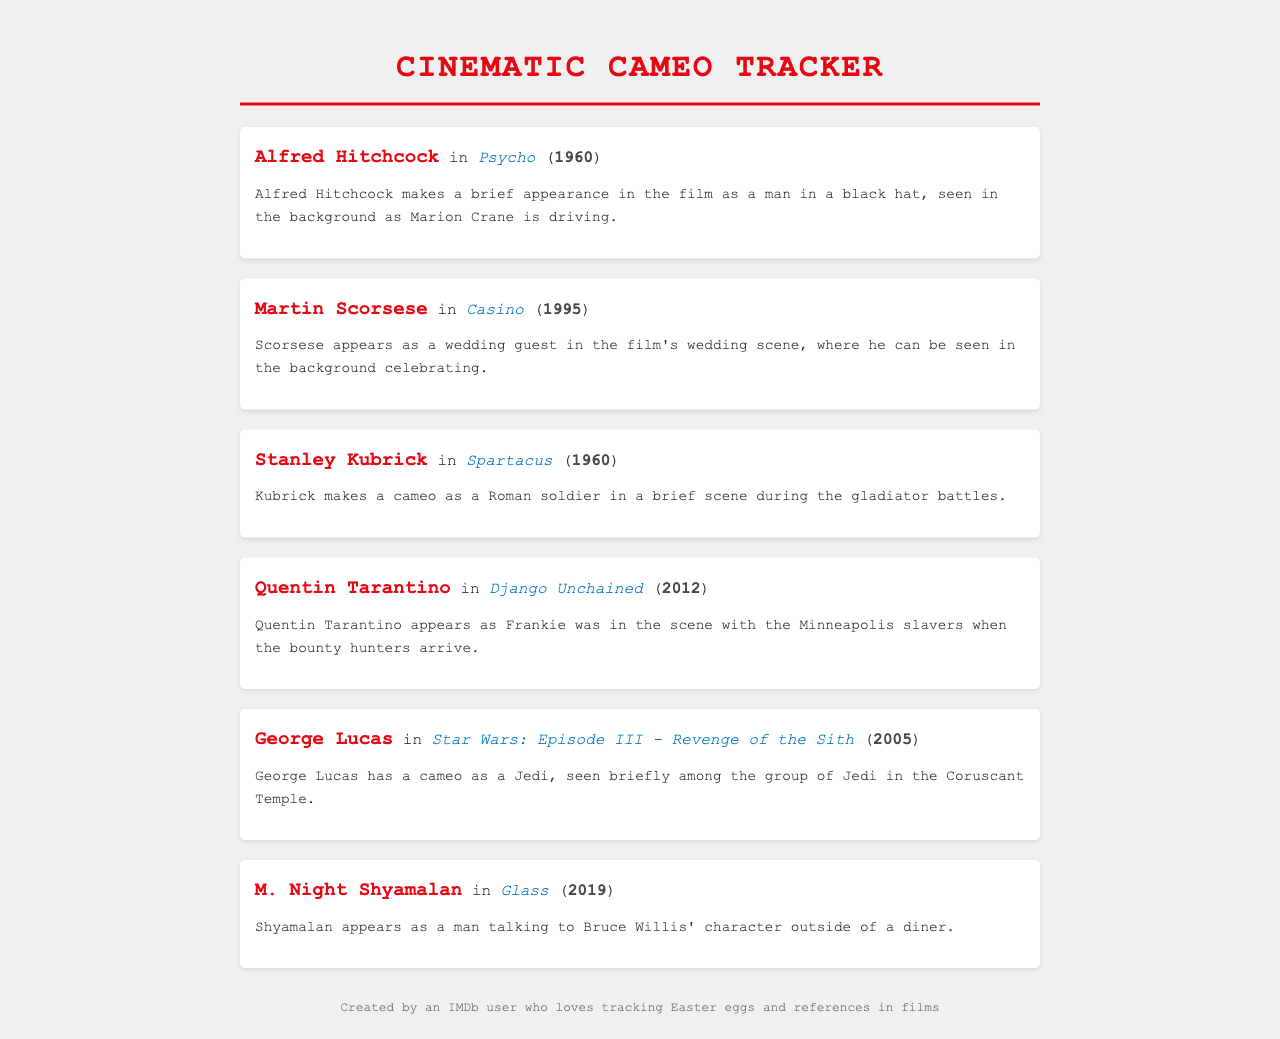What cameo did Alfred Hitchcock make? Alfred Hitchcock appears as a man in a black hat seen in the background as Marion Crane is driving in Psycho.
Answer: man in a black hat In which film did Martin Scorsese appear? Martin Scorsese appears in Casino as a wedding guest.
Answer: Casino What year was Stanley Kubrick's cameo in Spartacus? The document states that Kubrick's cameo in Spartacus took place in 1960.
Answer: 1960 What role did Quentin Tarantino play in Django Unchained? According to the document, Tarantino appears as Frankie in a scene with the Minneapolis slavers.
Answer: Frankie In which Star Wars episode did George Lucas make his cameo? The document indicates that George Lucas made his cameo in Star Wars: Episode III - Revenge of the Sith.
Answer: Episode III - Revenge of the Sith How does M. Night Shyamalan appear in Glass? Shyamalan appears as a man talking to Bruce Willis' character outside of a diner in Glass.
Answer: a man talking to Bruce Willis How many directors are mentioned in the document? The document lists six directors making cameos in various films.
Answer: six Which director appeared in both 1960 films? Both Alfred Hitchcock and Stanley Kubrick made their appearances in films released in 1960.
Answer: Alfred Hitchcock and Stanley Kubrick What is the common theme of the document? The document lists cameo appearances by famous directors in various films, highlighting their brief roles.
Answer: Cameo appearances by directors 